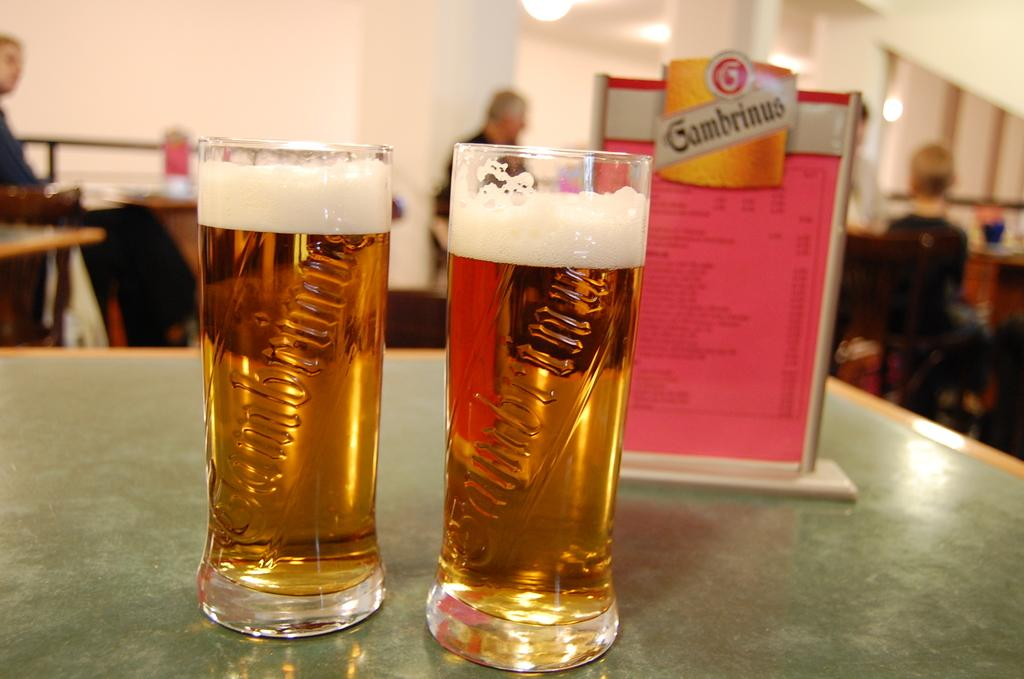<image>
Render a clear and concise summary of the photo. two glasses of beer with a Gambrinus logo in the background 